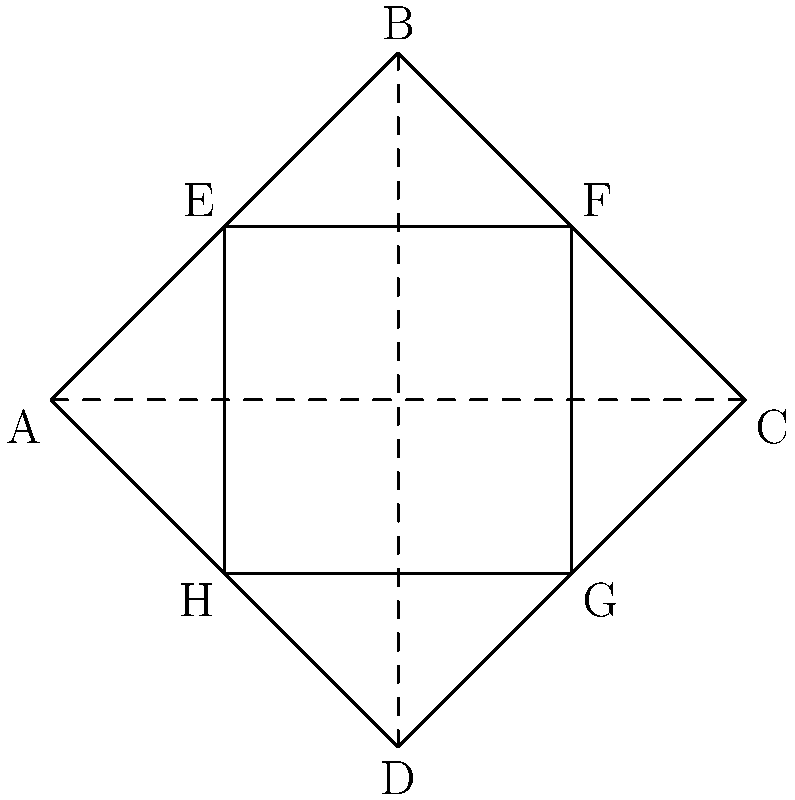In the iconic bow tie shape reminiscent of James Bond's signature accessory during Pierce Brosnan's era, ABCD forms the outer bow tie and EFGH forms the inner bow tie. If $\angle BAD = 60°$ and AC is perpendicular to BD, what is the measure of $\angle EFG$? Let's approach this step-by-step:

1) First, note that AC and BD are perpendicular and bisect each other. This means ABCD is a rhombus.

2) In a rhombus, opposite angles are equal. So, $\angle ABC = \angle ADC = 60°$ (given $\angle BAD = 60°$).

3) The sum of angles in a quadrilateral is 360°. So:
   $\angle BCD = 360° - (60° + 60° + 60°) = 180°$

4) This means that BC and CD form a straight line.

5) EFGH is similar to ABCD (they have the same shape, just different sizes).

6) Because BC and CD form a straight line, EF and FG also form a straight line.

7) In a straight line, adjacent angles are supplementary (add up to 180°).

8) Therefore, $\angle EFG = 180°$
Answer: 180° 